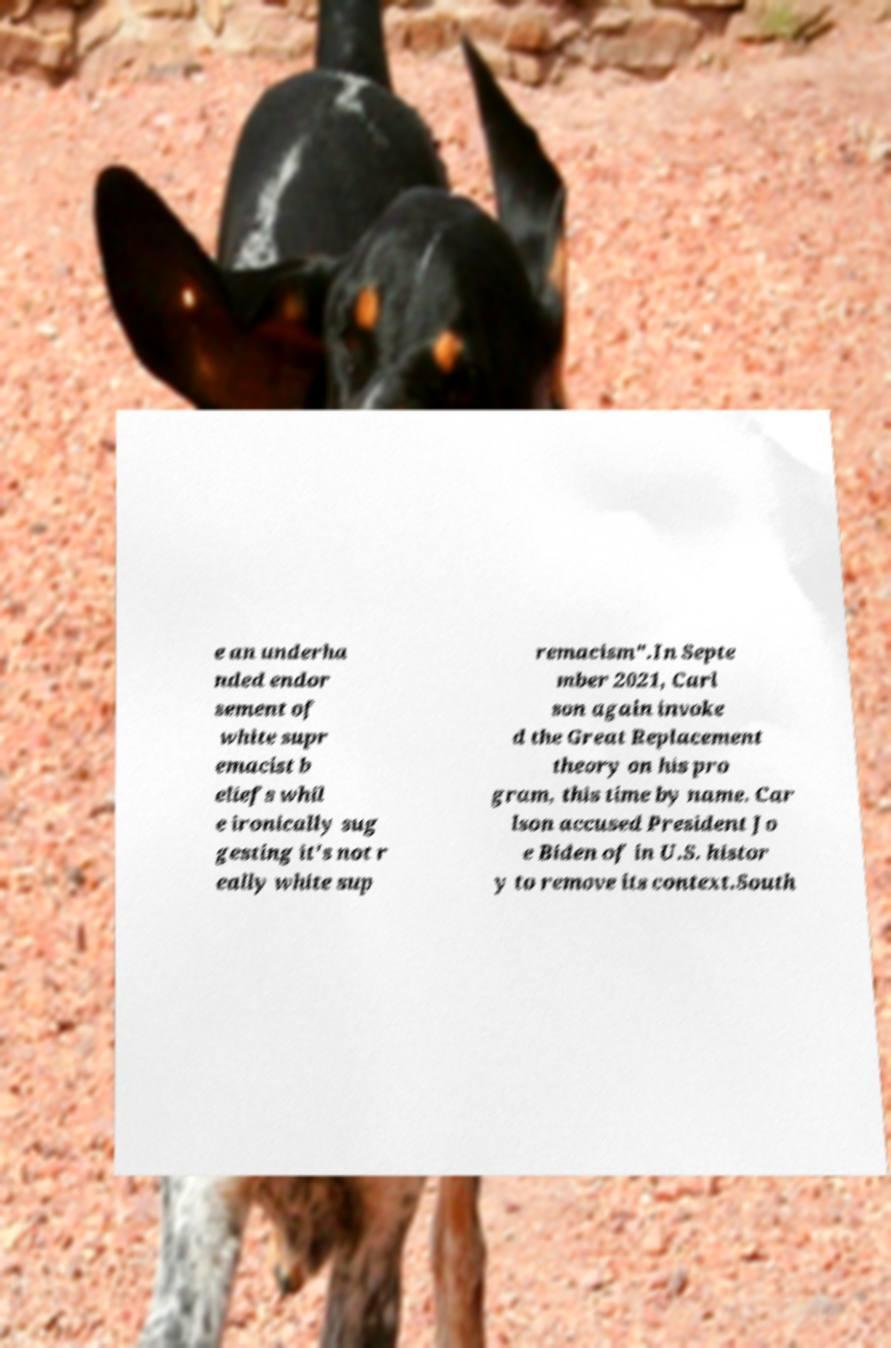Could you assist in decoding the text presented in this image and type it out clearly? e an underha nded endor sement of white supr emacist b eliefs whil e ironically sug gesting it's not r eally white sup remacism".In Septe mber 2021, Carl son again invoke d the Great Replacement theory on his pro gram, this time by name. Car lson accused President Jo e Biden of in U.S. histor y to remove its context.South 